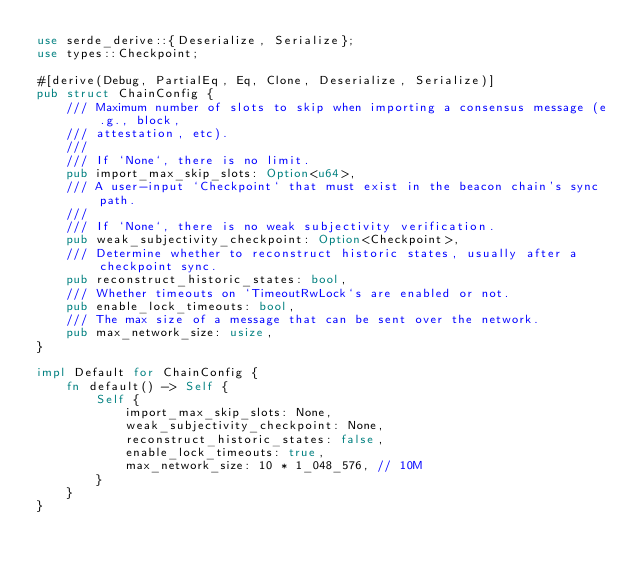<code> <loc_0><loc_0><loc_500><loc_500><_Rust_>use serde_derive::{Deserialize, Serialize};
use types::Checkpoint;

#[derive(Debug, PartialEq, Eq, Clone, Deserialize, Serialize)]
pub struct ChainConfig {
    /// Maximum number of slots to skip when importing a consensus message (e.g., block,
    /// attestation, etc).
    ///
    /// If `None`, there is no limit.
    pub import_max_skip_slots: Option<u64>,
    /// A user-input `Checkpoint` that must exist in the beacon chain's sync path.
    ///
    /// If `None`, there is no weak subjectivity verification.
    pub weak_subjectivity_checkpoint: Option<Checkpoint>,
    /// Determine whether to reconstruct historic states, usually after a checkpoint sync.
    pub reconstruct_historic_states: bool,
    /// Whether timeouts on `TimeoutRwLock`s are enabled or not.
    pub enable_lock_timeouts: bool,
    /// The max size of a message that can be sent over the network.
    pub max_network_size: usize,
}

impl Default for ChainConfig {
    fn default() -> Self {
        Self {
            import_max_skip_slots: None,
            weak_subjectivity_checkpoint: None,
            reconstruct_historic_states: false,
            enable_lock_timeouts: true,
            max_network_size: 10 * 1_048_576, // 10M
        }
    }
}
</code> 